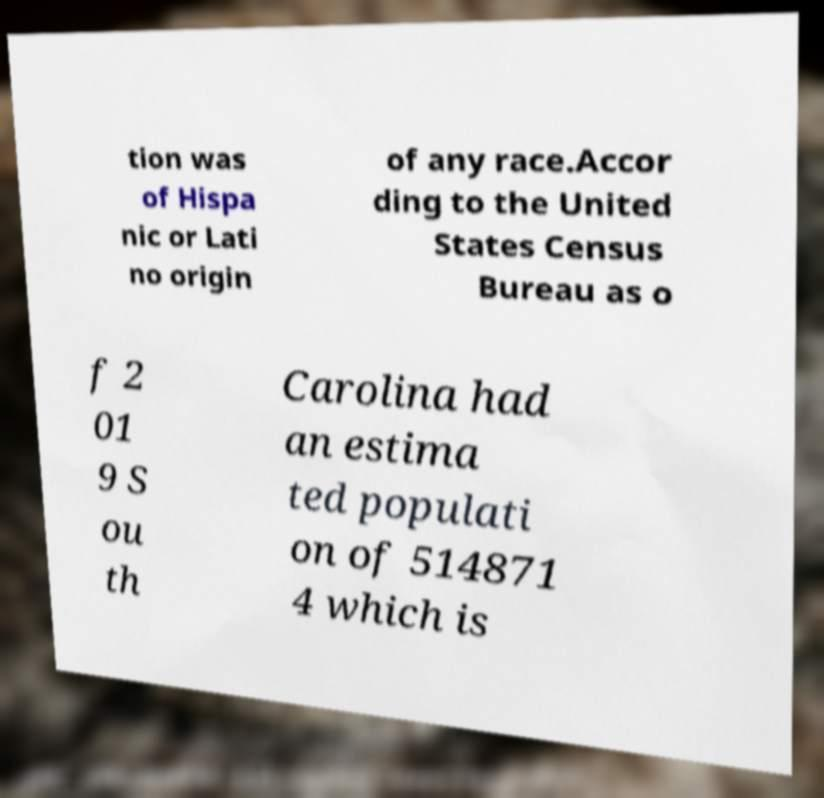Could you assist in decoding the text presented in this image and type it out clearly? tion was of Hispa nic or Lati no origin of any race.Accor ding to the United States Census Bureau as o f 2 01 9 S ou th Carolina had an estima ted populati on of 514871 4 which is 